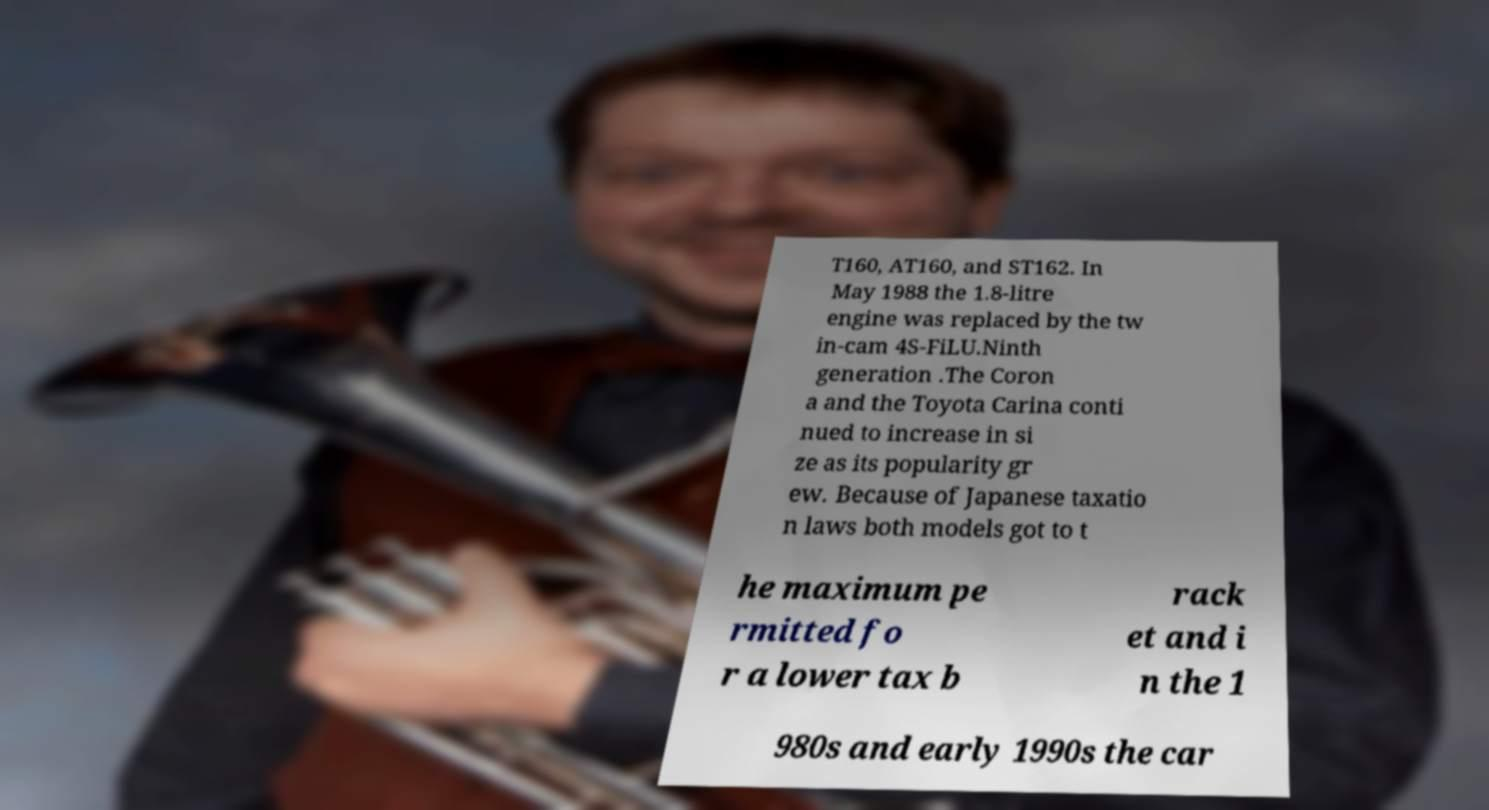What messages or text are displayed in this image? I need them in a readable, typed format. T160, AT160, and ST162. In May 1988 the 1.8-litre engine was replaced by the tw in-cam 4S-FiLU.Ninth generation .The Coron a and the Toyota Carina conti nued to increase in si ze as its popularity gr ew. Because of Japanese taxatio n laws both models got to t he maximum pe rmitted fo r a lower tax b rack et and i n the 1 980s and early 1990s the car 